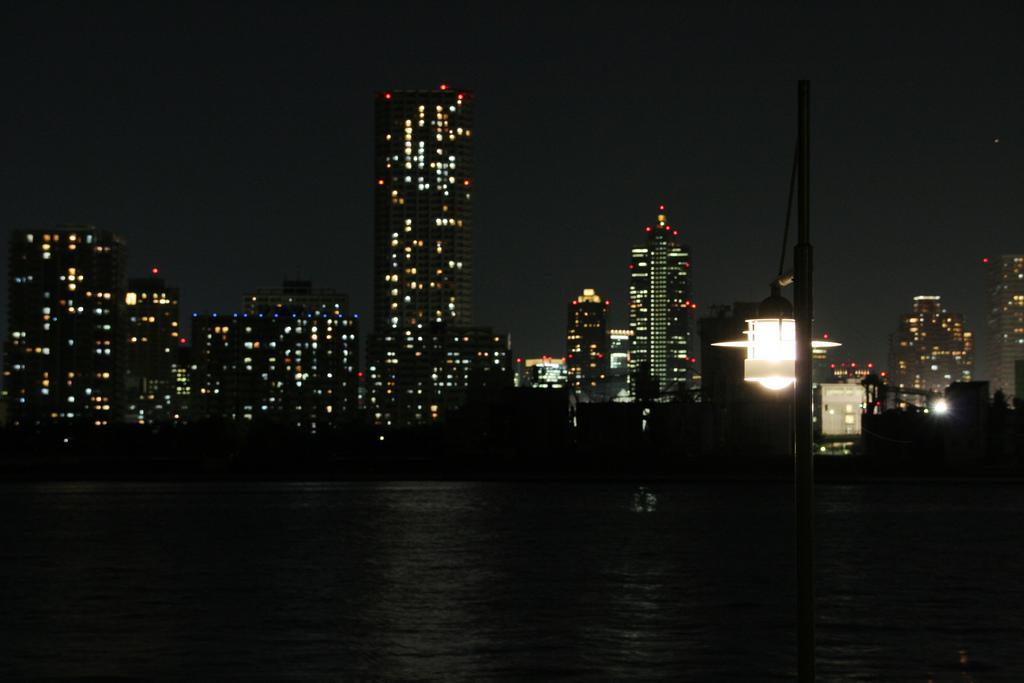In one or two sentences, can you explain what this image depicts? In this image in front there is water. There is a pole. There is a light. In the background of the image there are buildings, lights and sky. 